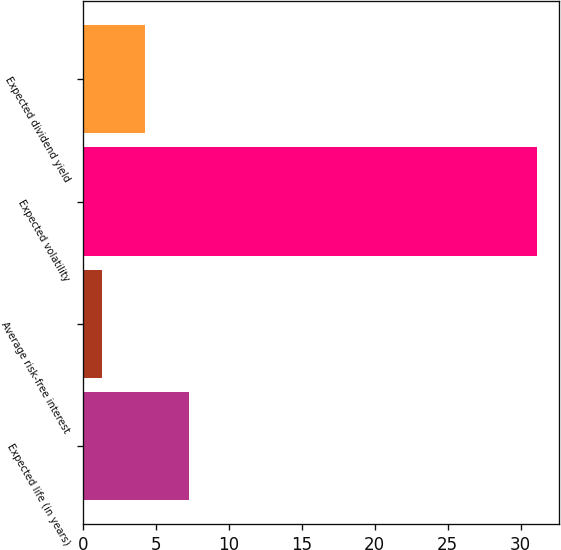<chart> <loc_0><loc_0><loc_500><loc_500><bar_chart><fcel>Expected life (in years)<fcel>Average risk-free interest<fcel>Expected volatility<fcel>Expected dividend yield<nl><fcel>7.26<fcel>1.3<fcel>31.1<fcel>4.28<nl></chart> 